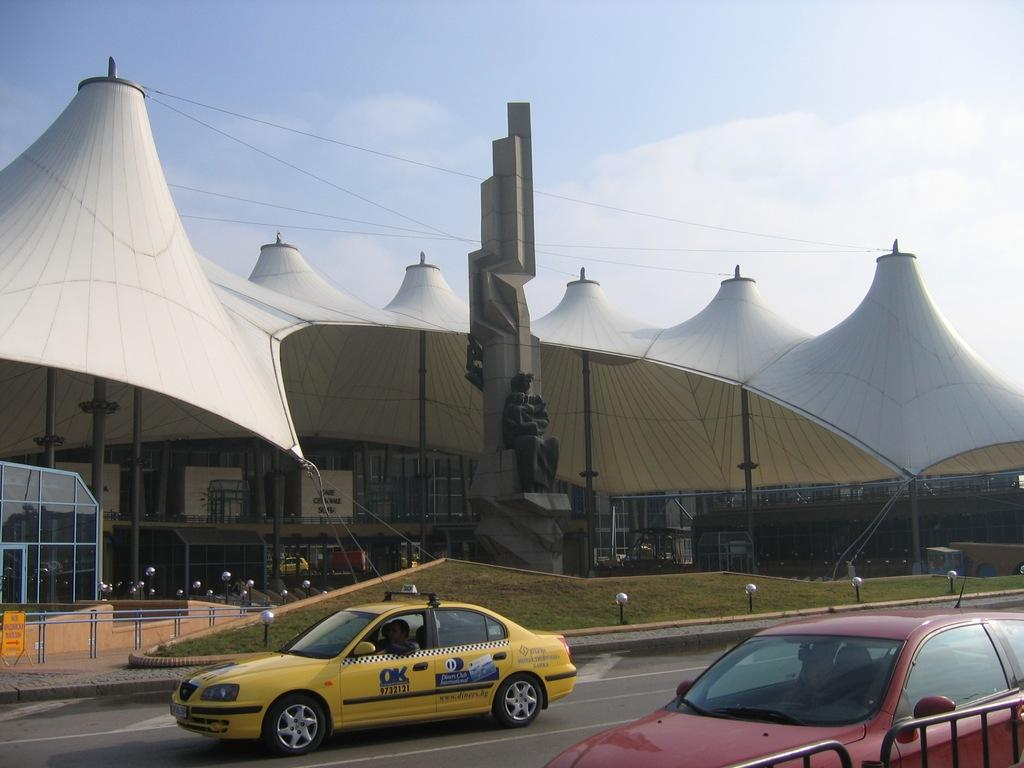Provide a one-sentence caption for the provided image. An OK cab in front of a landmark. 